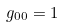<formula> <loc_0><loc_0><loc_500><loc_500>g _ { 0 0 } = 1</formula> 